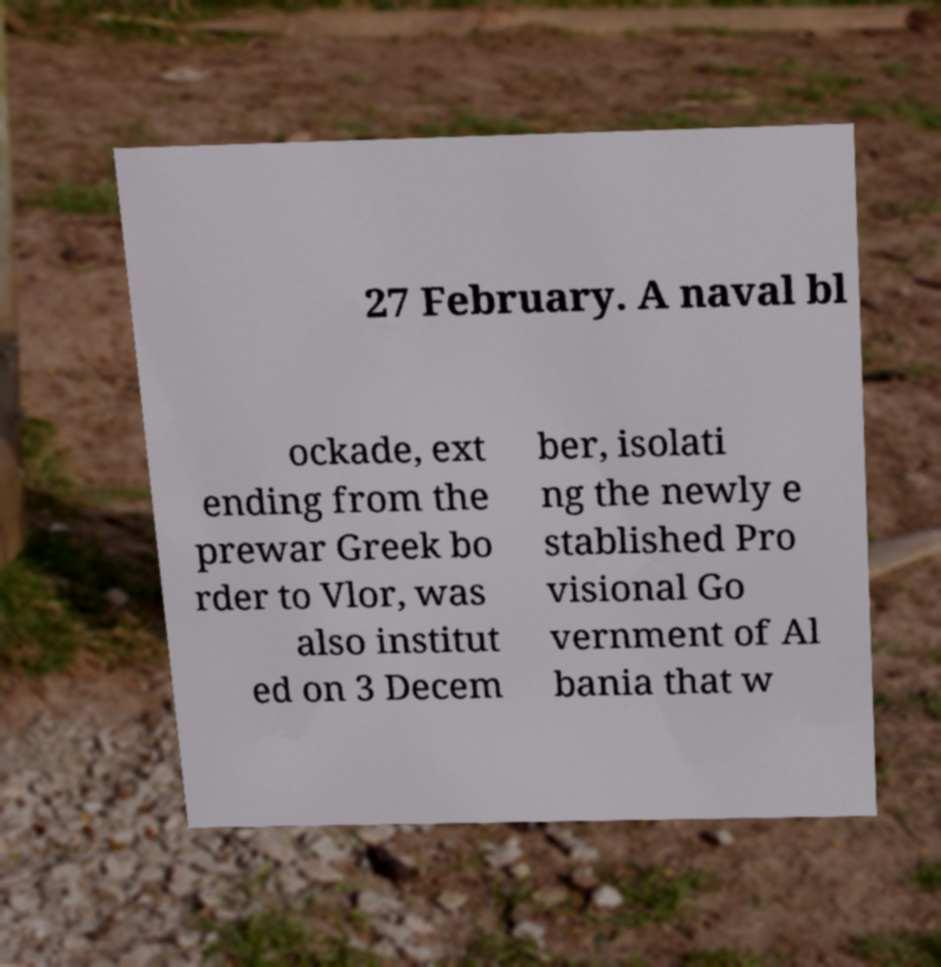What messages or text are displayed in this image? I need them in a readable, typed format. 27 February. A naval bl ockade, ext ending from the prewar Greek bo rder to Vlor, was also institut ed on 3 Decem ber, isolati ng the newly e stablished Pro visional Go vernment of Al bania that w 